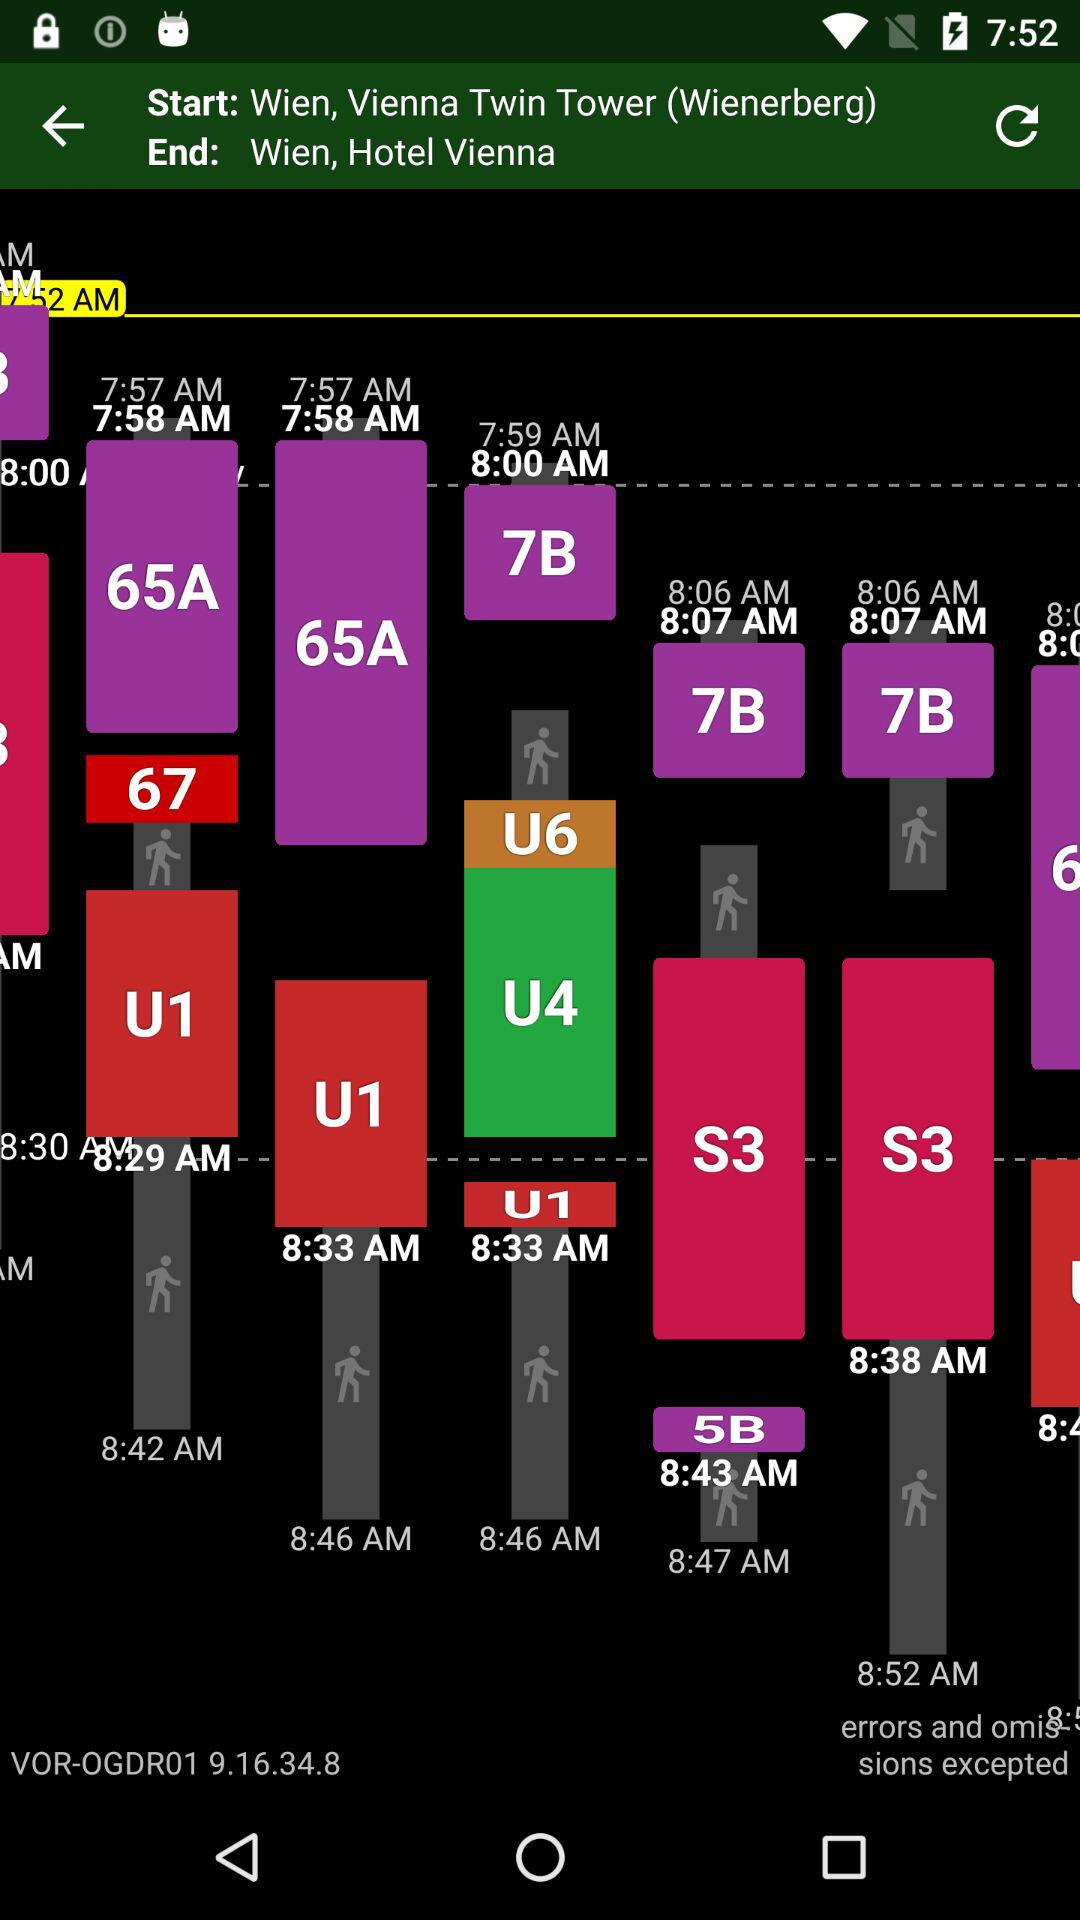How many minutes are there between the 8:29 and 8:33 times?
Answer the question using a single word or phrase. 4 